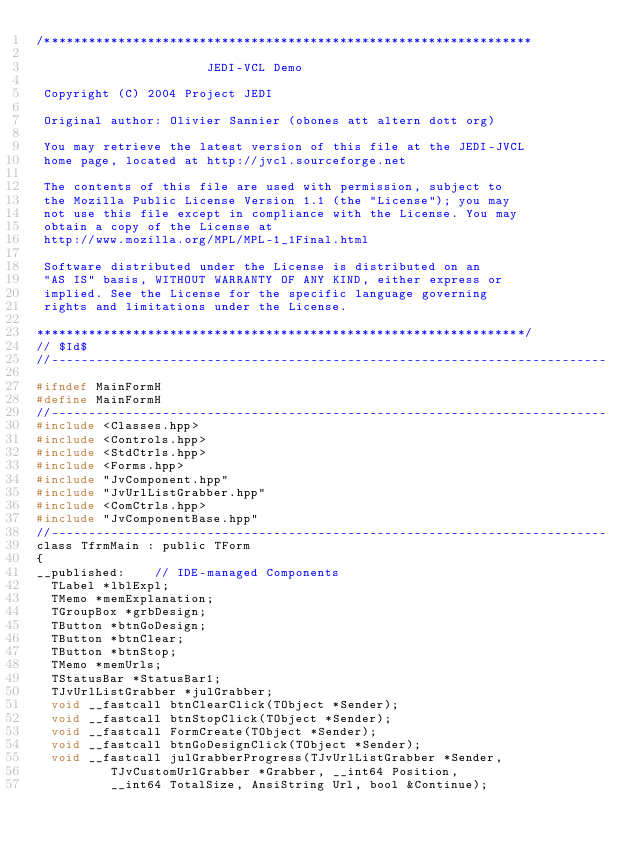Convert code to text. <code><loc_0><loc_0><loc_500><loc_500><_C_>/******************************************************************

                       JEDI-VCL Demo

 Copyright (C) 2004 Project JEDI

 Original author: Olivier Sannier (obones att altern dott org)

 You may retrieve the latest version of this file at the JEDI-JVCL
 home page, located at http://jvcl.sourceforge.net

 The contents of this file are used with permission, subject to
 the Mozilla Public License Version 1.1 (the "License"); you may
 not use this file except in compliance with the License. You may
 obtain a copy of the License at
 http://www.mozilla.org/MPL/MPL-1_1Final.html

 Software distributed under the License is distributed on an
 "AS IS" basis, WITHOUT WARRANTY OF ANY KIND, either express or
 implied. See the License for the specific language governing
 rights and limitations under the License.

******************************************************************/
// $Id$
//---------------------------------------------------------------------------

#ifndef MainFormH
#define MainFormH
//---------------------------------------------------------------------------
#include <Classes.hpp>
#include <Controls.hpp>
#include <StdCtrls.hpp>
#include <Forms.hpp>
#include "JvComponent.hpp"
#include "JvUrlListGrabber.hpp"
#include <ComCtrls.hpp>
#include "JvComponentBase.hpp"
//---------------------------------------------------------------------------
class TfrmMain : public TForm
{
__published:	// IDE-managed Components
  TLabel *lblExpl;
  TMemo *memExplanation;
  TGroupBox *grbDesign;
  TButton *btnGoDesign;
  TButton *btnClear;
  TButton *btnStop;
  TMemo *memUrls;
  TStatusBar *StatusBar1;
  TJvUrlListGrabber *julGrabber;
  void __fastcall btnClearClick(TObject *Sender);
  void __fastcall btnStopClick(TObject *Sender);
  void __fastcall FormCreate(TObject *Sender);
  void __fastcall btnGoDesignClick(TObject *Sender);
  void __fastcall julGrabberProgress(TJvUrlListGrabber *Sender,
          TJvCustomUrlGrabber *Grabber, __int64 Position,
          __int64 TotalSize, AnsiString Url, bool &Continue);</code> 